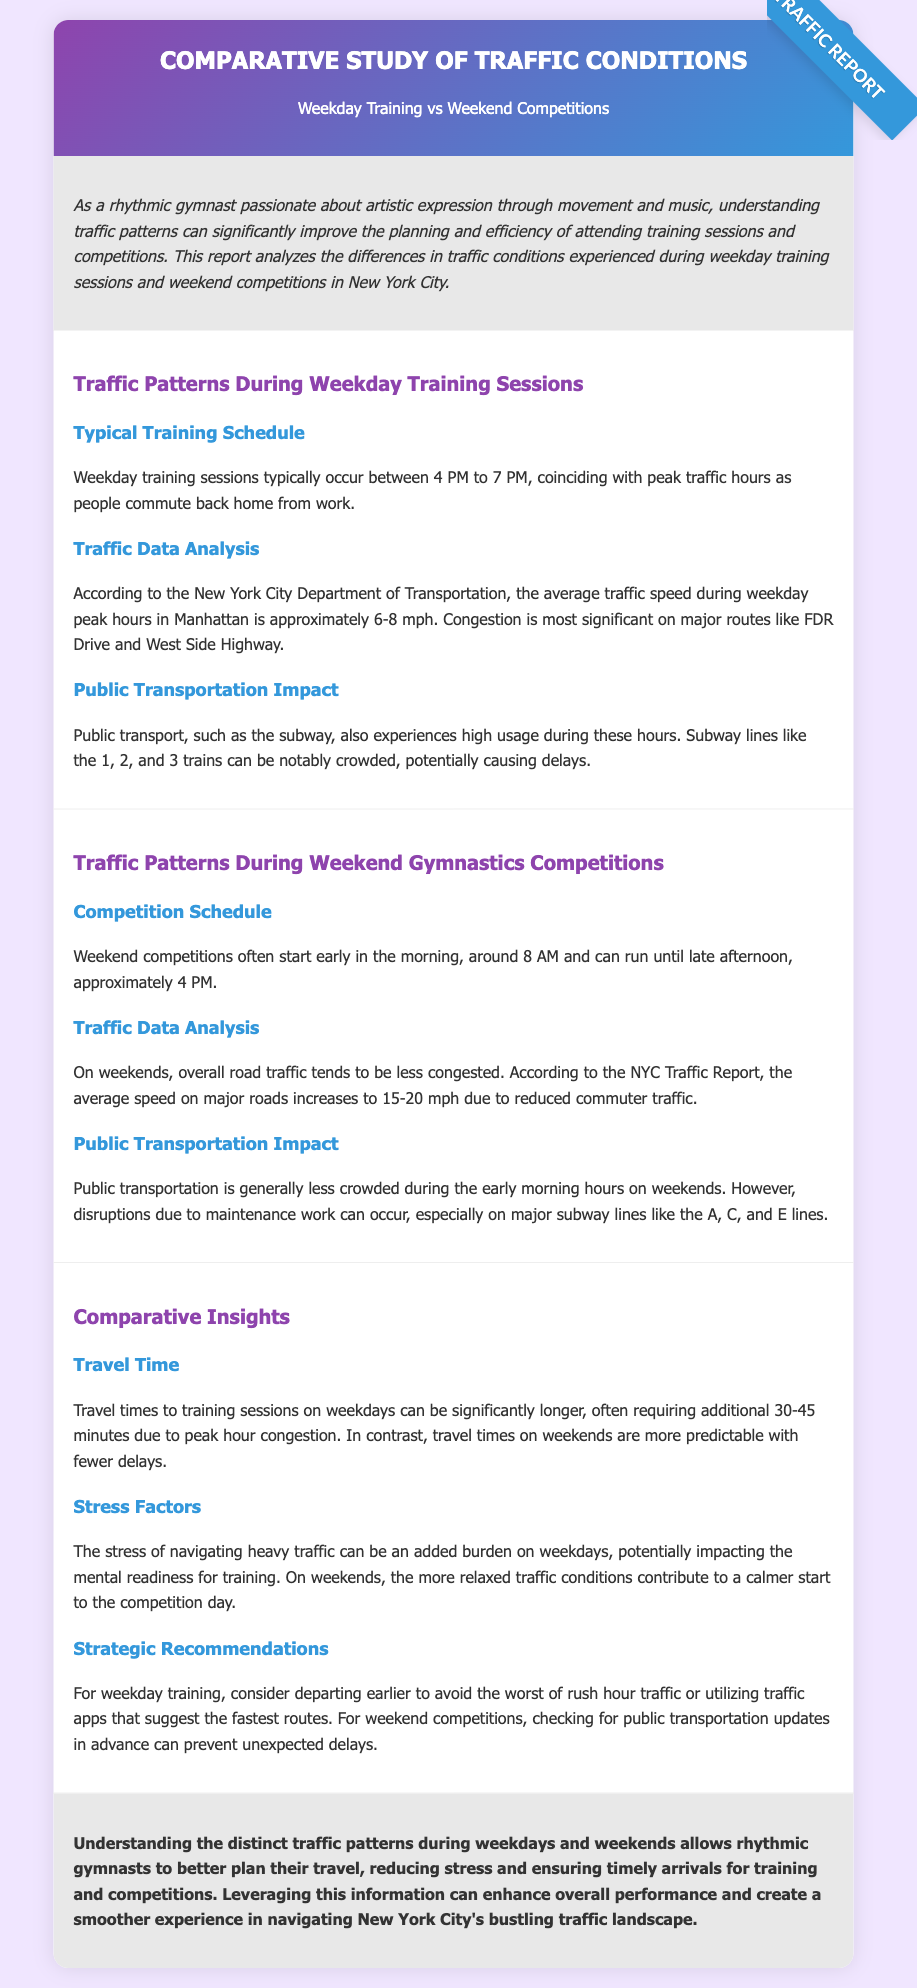What is the typical training schedule time? The typical training schedule occurs between 4 PM to 7 PM on weekdays.
Answer: 4 PM to 7 PM What is the average traffic speed during weekday peak hours in Manhattan? The average traffic speed during weekday peak hours in Manhattan is approximately 6-8 mph.
Answer: 6-8 mph When do weekend competitions typically start? Weekend competitions typically start early in the morning, around 8 AM.
Answer: 8 AM What is the average speed on major roads during weekends? The average speed on major roads during weekends increases to 15-20 mph due to reduced commuter traffic.
Answer: 15-20 mph What can increase travel time to training sessions on weekdays? Travel times can be significantly longer due to peak hour congestion requiring additional 30-45 minutes.
Answer: 30-45 minutes How does traffic on weekends affect mental readiness for competitions? The relaxed traffic conditions contribute to a calmer start to the competition day.
Answer: Calmer start What is a recommended strategy for weekday training travel? Consider departing earlier to avoid the worst of rush hour traffic.
Answer: Depart earlier What is a common reason for disruptions in public transportation on weekends? Disruptions are mainly due to maintenance work on major subway lines.
Answer: Maintenance work Which specific subway lines are crowded during weekday sessions? Subway lines like the 1, 2, and 3 trains are notably crowded.
Answer: 1, 2, and 3 trains 